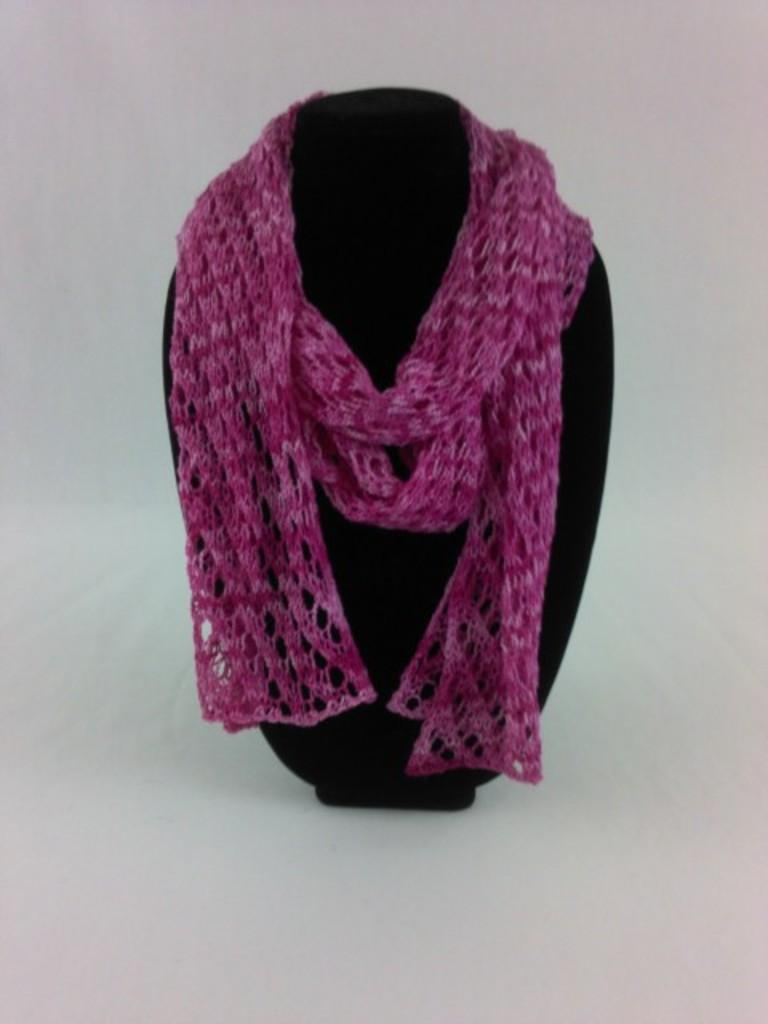What is the color of the stole in the image? The stole in the image is pink. What is the stole placed on? The pink stole is on a black object. What is the color of the surface beneath the black object? The black object is placed on a white surface. What type of lettuce is visible in the image? There is no lettuce present in the image. 